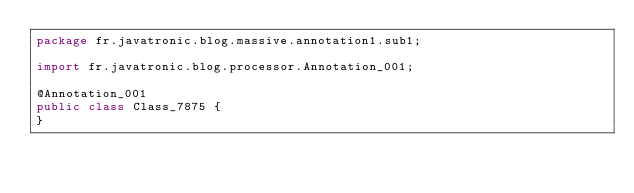Convert code to text. <code><loc_0><loc_0><loc_500><loc_500><_Java_>package fr.javatronic.blog.massive.annotation1.sub1;

import fr.javatronic.blog.processor.Annotation_001;

@Annotation_001
public class Class_7875 {
}
</code> 